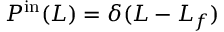Convert formula to latex. <formula><loc_0><loc_0><loc_500><loc_500>P ^ { i n } ( L ) = \delta ( L - L _ { f } )</formula> 